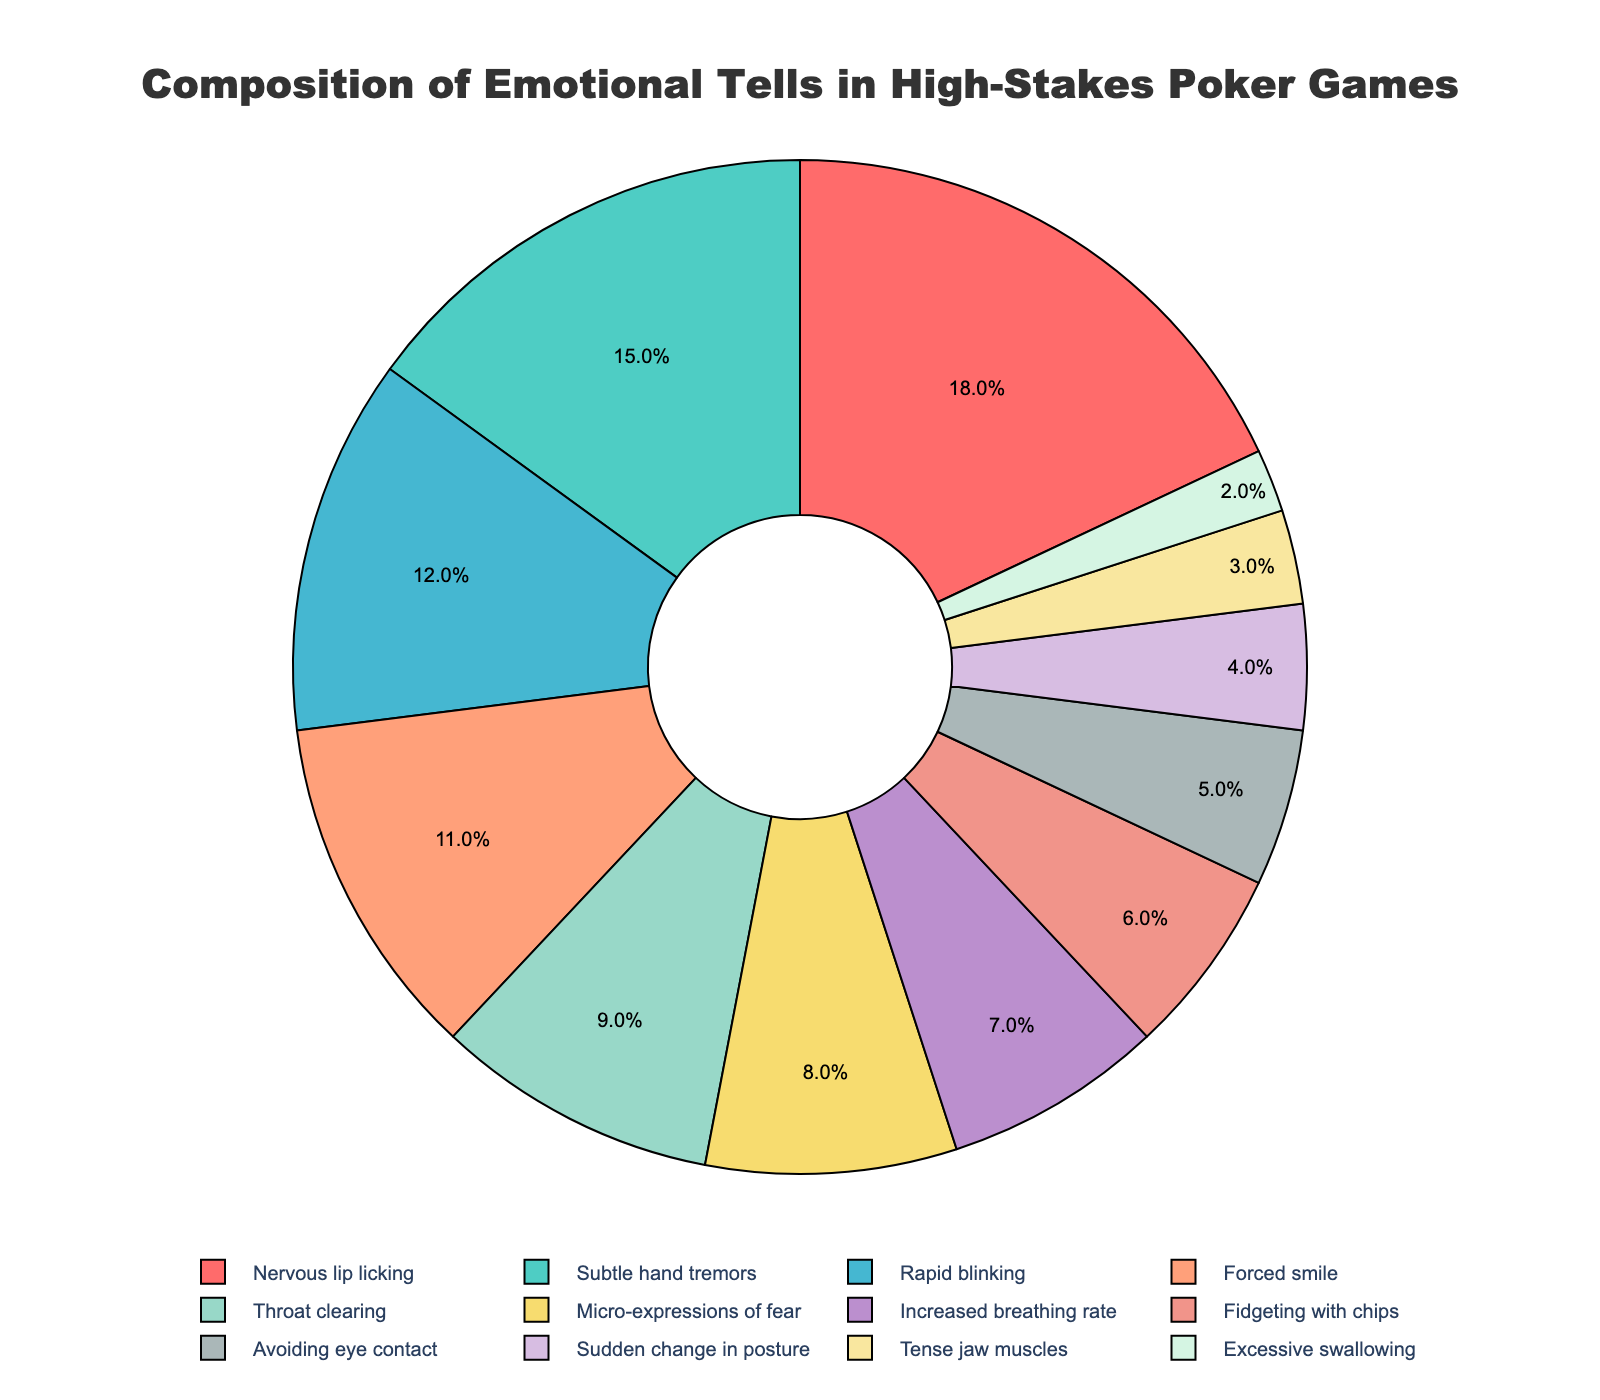Which emotional tell has the highest percentage? To find which emotional tell has the highest percentage, look for the segment with the largest size or the highest percentage label in the pie chart.
Answer: Nervous lip licking What is the combined percentage of Rapid blinking and Micro-expressions of fear? Add the percentage of Rapid blinking (12%) and Micro-expressions of fear (8%) together to get the combined percentage.
Answer: 20% Which emotional tell accounts for exactly 5% of the composition? Identify the segment labeled with 5% on the pie chart.
Answer: Avoiding eye contact How much more frequent is Nervous lip licking compared to Excessive swallowing? Subtract the percentage of Excessive swallowing (2%) from the percentage of Nervous lip licking (18%) to find the difference.
Answer: 16% What is the sum of the percentages of Subtle hand tremors and Forced smile? Add the percentages of Subtle hand tremors (15%) and Forced smile (11%) together to get the total percentage.
Answer: 26% Which emotional tells have percentages less than 5%? Identify the segments on the pie chart with percentages less than 5%.
Answer: Sudden change in posture, Tense jaw muscles, Excessive swallowing Is the percentage of Forced smile greater than the percentage of Throat clearing? Compare the percentage of Forced smile (11%) with the percentage of Throat clearing (9%).
Answer: Yes What color represents Rapid blinking on the pie chart? Check the color used for the segment labeled as Rapid blinking.
Answer: Blue Which two emotional tells have the smallest differences in their percentages? Find the pairs of emotional tells and calculate the differences between their percentages, identifying the smallest differences.
Answer: Increased breathing rate and fidgeting with chips If you were to combine the percentages of Fidgeting with chips and Avoiding eye contact, would it be higher than Micro-expressions of fear? Add the percentages of Fidgeting with chips (6%) and Avoiding eye contact (5%) and compare the sum with Micro-expressions of fear (8%).
Answer: Yes 